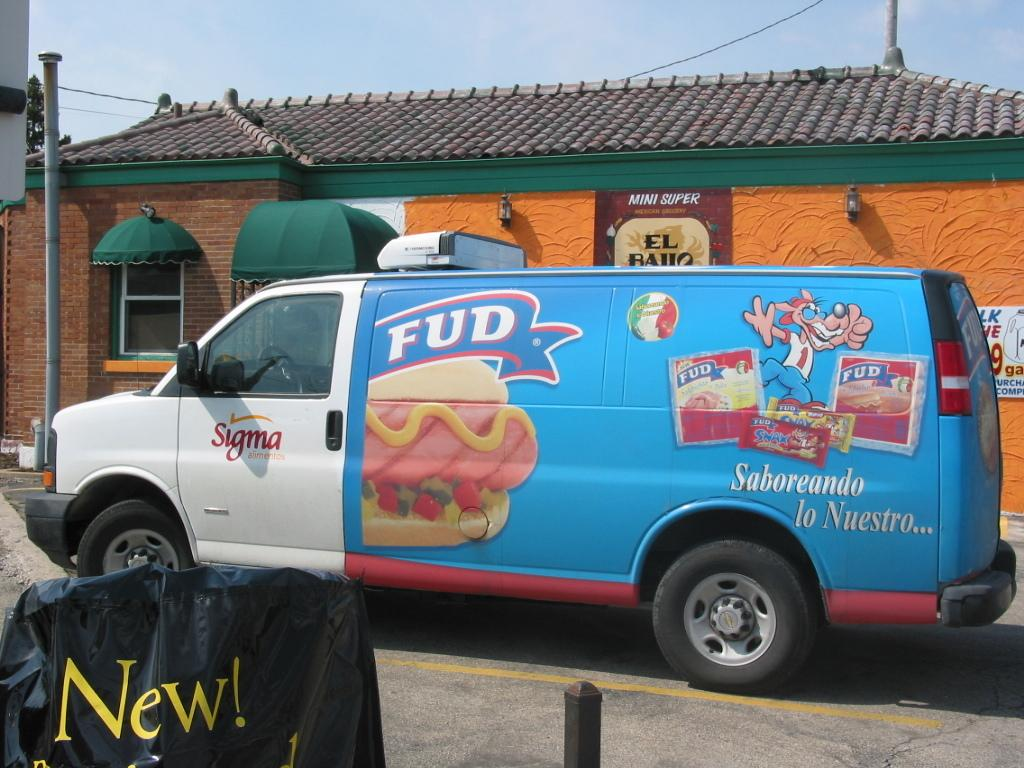<image>
Describe the image concisely. A Sigma truck has the word FUD and a hot dog on the side of it. 